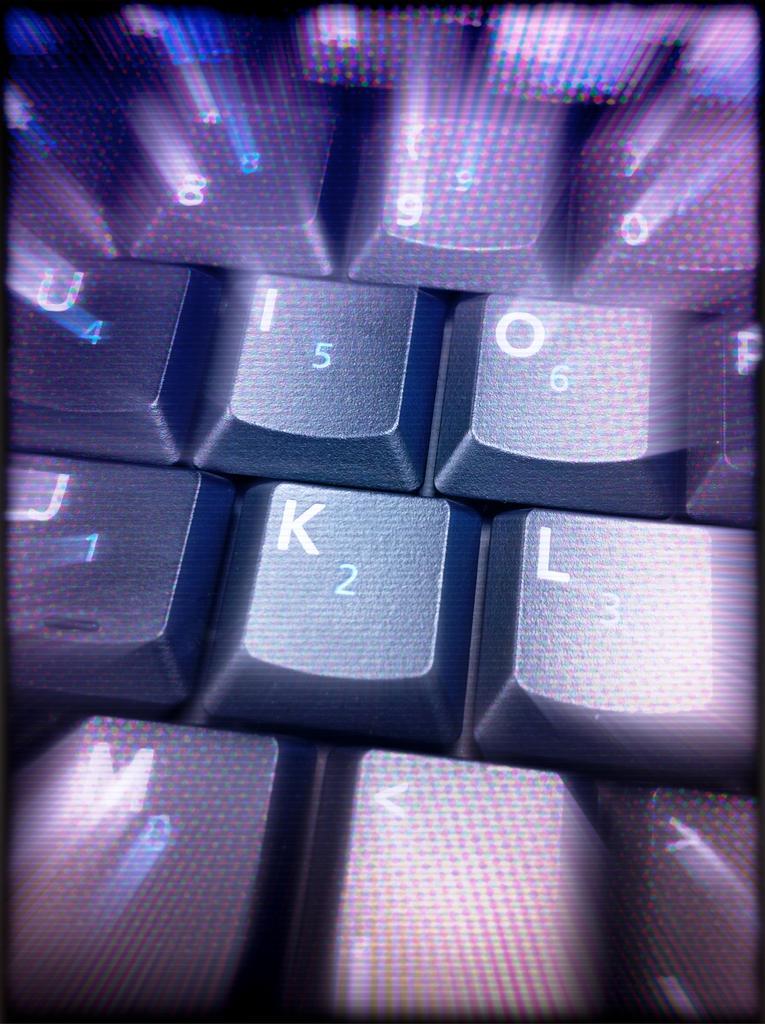Can you describe this image briefly? This is an edited image. In this image I can see the key buttons with some letters and numbers. 